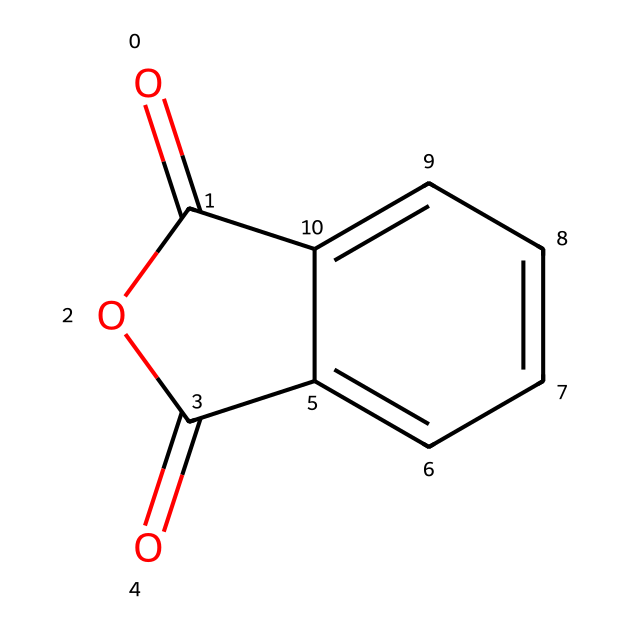What is the molecular formula of phthalic anhydride? The structure can be analyzed for its constituent atoms: there are 8 carbon (C) atoms, 4 oxygen (O) atoms, and 4 hydrogen (H) atoms in total. Thus, the molecular formula is derived by summing the atoms in the visual representation.
Answer: C8H4O3 How many rings are present in the structure? By examining the SMILES representation, we can see that two cycles are formed in the structure; one is a five-membered anhydride ring, and the other is a benzene ring. The "c" indicates the carbon atoms in a ring, with two rings accounted for.
Answer: 2 What functional groups are present in phthalic anhydride? In the structure, the presence of the anhydride functional group is indicated by the "O=C1OC(=O)" portion where the carbonyl and ether-like characteristics are noted. The other significant functional group is the aromatic ring.
Answer: anhydride and aromatic What is the degree of unsaturation in this compound? The degree of unsaturation can be calculated using the formula: (number of C - number of H + number of N + 1) / 2. For phthalic anhydride, there are 8 carbons, 4 hydrogens, hence (8 - 4 + 0 + 1)/2 = 2. This indicates the presence of 2 rings or double bonds in the structure.
Answer: 2 Is phthalic anhydride an acid or a base? By examining its structure and comparing it to well-known acid anhydrides, we conclude that phthalic anhydride possesses acidic properties as indicated by the presence of carbonyl groups that can donate protons.
Answer: acid What type of polymerization does phthalic anhydride undergo? Phthalic anhydride is typically involved in step-growth polymerization processes where it reacts with diols to produce polyesters, leveraging the anhydride functionalization to form ester bonds during polymerization.
Answer: step-growth What is the primary use of phthalic anhydride? The primary application of phthalic anhydride, as indicated by its structure and associated functional groups, is in the production of plasticizers which are critical for user interface materials, enhancing flexibility and durability.
Answer: plasticizers 